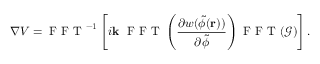Convert formula to latex. <formula><loc_0><loc_0><loc_500><loc_500>\nabla V = F F T ^ { - 1 } \left [ i k F F T \left ( \frac { \partial w ( \tilde { \phi } ( r ) ) } { \partial \tilde { \phi } } \right ) F F T ( \mathcal { G } ) \right ] .</formula> 